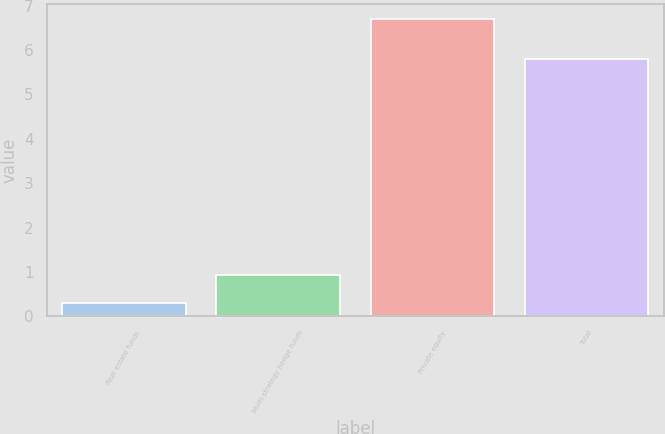<chart> <loc_0><loc_0><loc_500><loc_500><bar_chart><fcel>Real estate funds<fcel>Multi-strategy hedge funds<fcel>Private equity<fcel>Total<nl><fcel>0.3<fcel>0.94<fcel>6.7<fcel>5.8<nl></chart> 